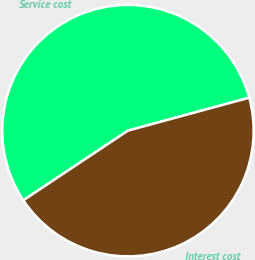<chart> <loc_0><loc_0><loc_500><loc_500><pie_chart><fcel>Service cost<fcel>Interest cost<nl><fcel>55.13%<fcel>44.87%<nl></chart> 